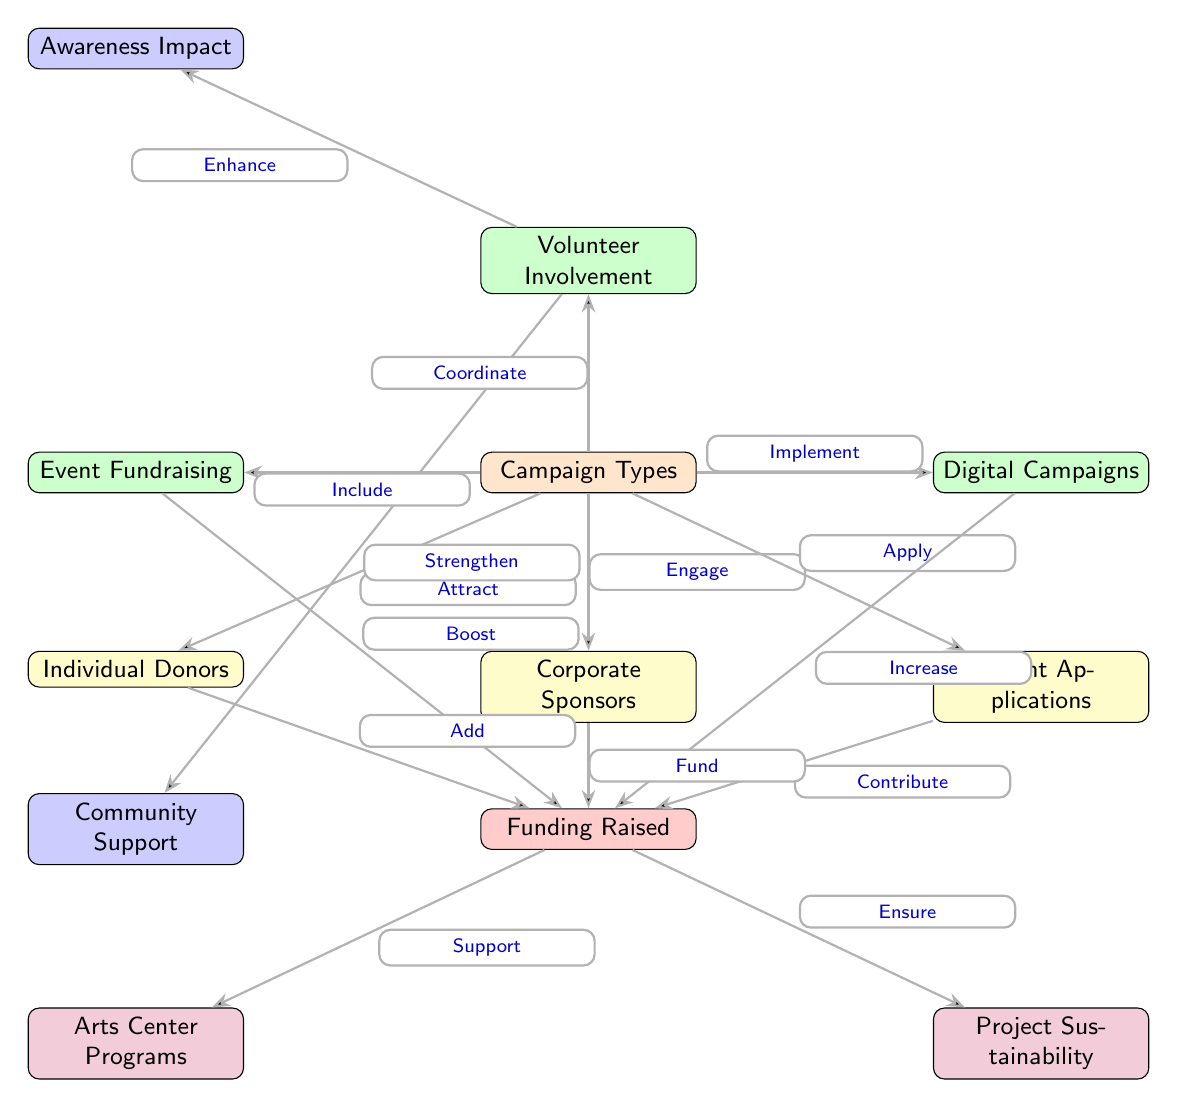What are the main campaign types listed in the diagram? The diagram identifies several types of campaigns, which are presented in the central "Campaign Types" node. These include "Individual Donors," "Corporate Sponsors," "Grant Applications," "Event Fundraising," and "Digital Campaigns."
Answer: Individual Donors, Corporate Sponsors, Grant Applications, Event Fundraising, Digital Campaigns How does "Event Fundraising" affect "Funding Raised"? The diagram shows that "Event Fundraising" connects to "Funding Raised" with the edge labeled "Boost." This indicates a positive contribution of event fundraising on the total funds raised.
Answer: Boost What is the relationship between "Funding Raised" and "Project Sustainability"? The edge labeled "Ensure" connects "Funding Raised" to "Project Sustainability." This signifies that the amount of funding raised is critical for ensuring the sustainability of projects.
Answer: Ensure Which entity contributes to "Funding Raised" by "Applying"? The diagram indicates that "Grant Applications" contribute to "Funding Raised" through the edge labeled "Contribute." This shows that the process of applying for grants is a way to generate funds.
Answer: Grant Applications What element enhances "Awareness Impact"? According to the diagram, "Volunteer Involvement" enhances "Awareness Impact," as the edge points from volunteer involvement to awareness impact with the label "Enhance."
Answer: Volunteer Involvement How many nodes are associated with "Community Support"? The diagram shows only one direct connection to "Community Support," which is from "Funding Raised" with the edge labeled "Strengthen." Therefore, there is one node specifically related to community support.
Answer: One What is the purpose of "Digital Campaigns" in relation to "Funding Raised"? "Digital Campaigns" are linked to "Funding Raised" with the edge labeled "Increase," indicating that digital campaigns serve to increase the total funds raised through fundraising efforts.
Answer: Increase What type of support do "Corporate Sponsors" provide? The edge labeled "Fund" connects "Corporate Sponsors" to "Funding Raised," indicating that corporate sponsors provide financial support through their contributions.
Answer: Fund Which campaign type is mentioned as "Including" in the diagram? The diagram indicates that "Event Fundraising" is included in the "Campaign Types," as described by the edge labeled "Include," which shows that it's one of the campaign strategies used.
Answer: Event Fundraising 